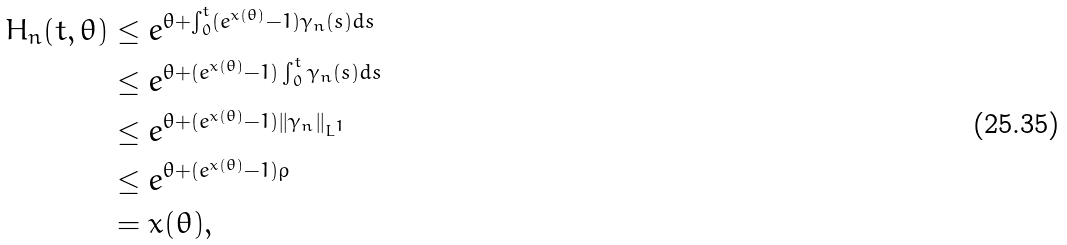<formula> <loc_0><loc_0><loc_500><loc_500>H _ { n } ( t , \theta ) & \leq e ^ { \theta + \int _ { 0 } ^ { t } ( e ^ { x ( \theta ) } - 1 ) \gamma _ { n } ( s ) d s } \\ & \leq e ^ { \theta + ( e ^ { x ( \theta ) } - 1 ) \int _ { 0 } ^ { t } \gamma _ { n } ( s ) d s } \\ & \leq e ^ { \theta + ( e ^ { x ( \theta ) } - 1 ) \| \gamma _ { n } \| _ { L ^ { 1 } } } \\ & \leq e ^ { \theta + ( e ^ { x ( \theta ) } - 1 ) \rho } \\ & = x ( \theta ) ,</formula> 